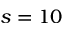Convert formula to latex. <formula><loc_0><loc_0><loc_500><loc_500>s = 1 0</formula> 